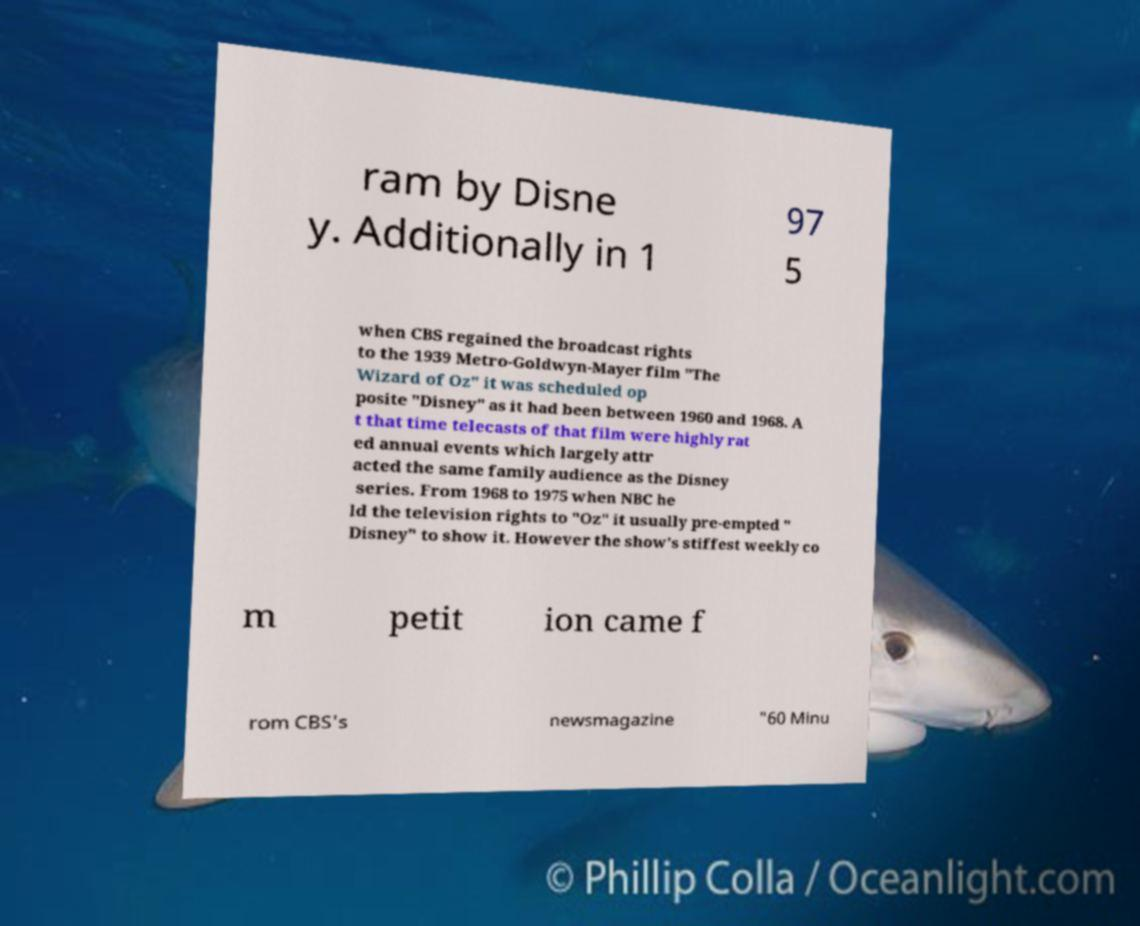For documentation purposes, I need the text within this image transcribed. Could you provide that? ram by Disne y. Additionally in 1 97 5 when CBS regained the broadcast rights to the 1939 Metro-Goldwyn-Mayer film "The Wizard of Oz" it was scheduled op posite "Disney" as it had been between 1960 and 1968. A t that time telecasts of that film were highly rat ed annual events which largely attr acted the same family audience as the Disney series. From 1968 to 1975 when NBC he ld the television rights to "Oz" it usually pre-empted " Disney" to show it. However the show's stiffest weekly co m petit ion came f rom CBS's newsmagazine "60 Minu 